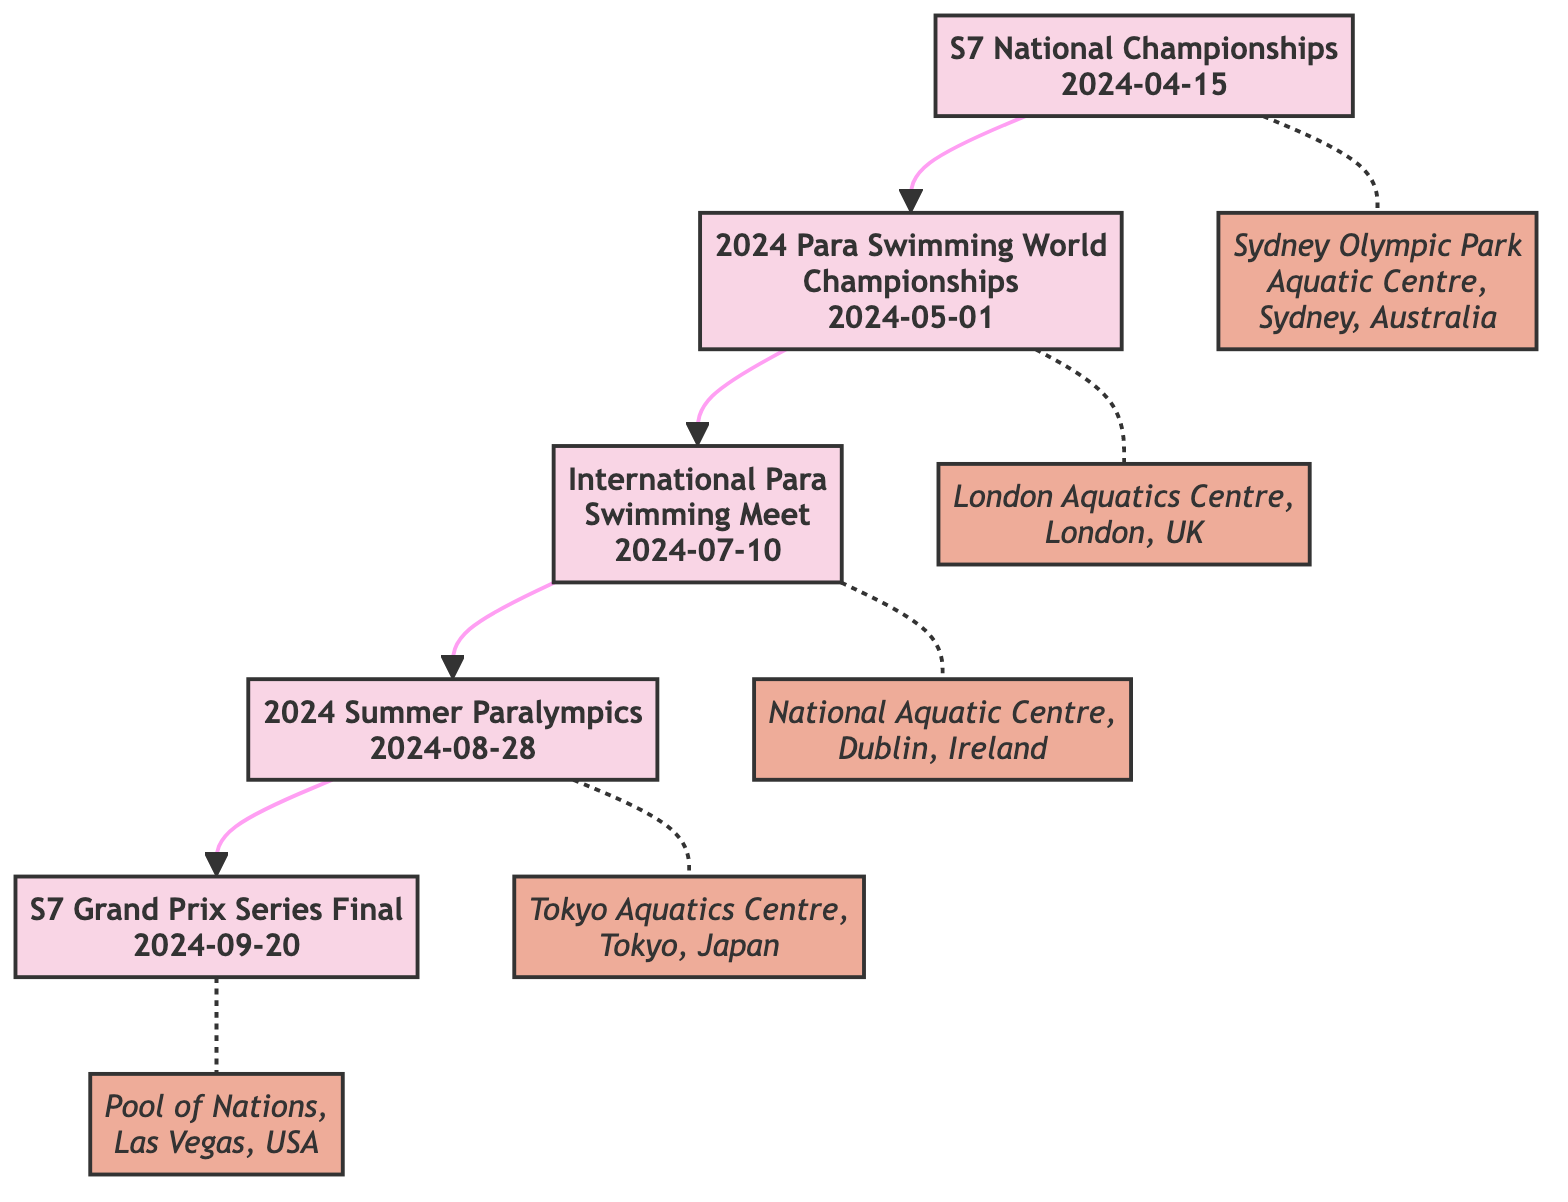What is the first event in the timeline? The first event listed in the diagram is the "S7 National Championships" scheduled for "2024-04-15". It is the initial node from which all subsequent events flow.
Answer: S7 National Championships How many events are shown in the diagram? By counting the distinct events listed in the diagram, there are five events in total. Each event has a unique identifier and date on the graph.
Answer: 5 What is the date of the "International Para Swimming Meet"? The date is mentioned directly next to the event node in the diagram as "2024-07-10". This date is linked sequentially from the prior event.
Answer: 2024-07-10 Which event follows the "2024 Para Swimming World Championships"? The diagram shows that the "International Para Swimming Meet" comes directly after the "2024 Para Swimming World Championships", connected through a directed edge.
Answer: International Para Swimming Meet Where will the "S7 Grand Prix Series Final" take place? The label in the diagram specifies the location of the "S7 Grand Prix Series Final" as "Pool of Nations, Las Vegas, USA". This information is positioned near the event node.
Answer: Pool of Nations, Las Vegas, USA What event occurs after the "S7 National Championships"? Following the "S7 National Championships", the next event indicated in the flow is the "2024 Para Swimming World Championships". This sequential connection moves to the subsequent node.
Answer: 2024 Para Swimming World Championships Which event is scheduled for the latest date in the timeline? The latest event in the timeline is the "S7 Grand Prix Series Final", which is scheduled for "2024-09-20". It is the final node in the progression of events.
Answer: S7 Grand Prix Series Final How many events take place in the summer months? In the timeline presented, two events occur during summer: the "International Para Swimming Meet" on "2024-07-10" and the "2024 Summer Paralympics" on "2024-08-28". By identifying the months of these events, the answer can be deduced.
Answer: 2 What is the location of the "2024 Summer Paralympics"? According to the diagram, the location of the "2024 Summer Paralympics" is "Tokyo Aquatics Centre, Tokyo, Japan", which is explicitly mentioned alongside the event.
Answer: Tokyo Aquatics Centre, Tokyo, Japan 